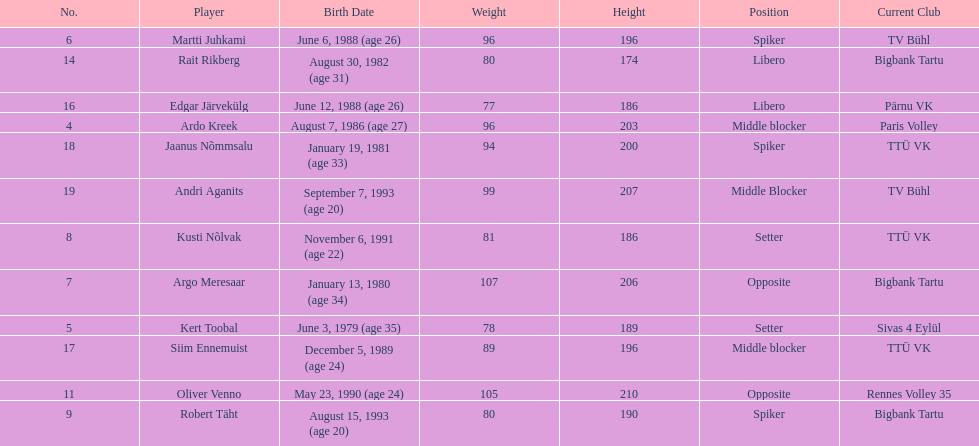Which players played the same position as ardo kreek? Siim Ennemuist, Andri Aganits. 